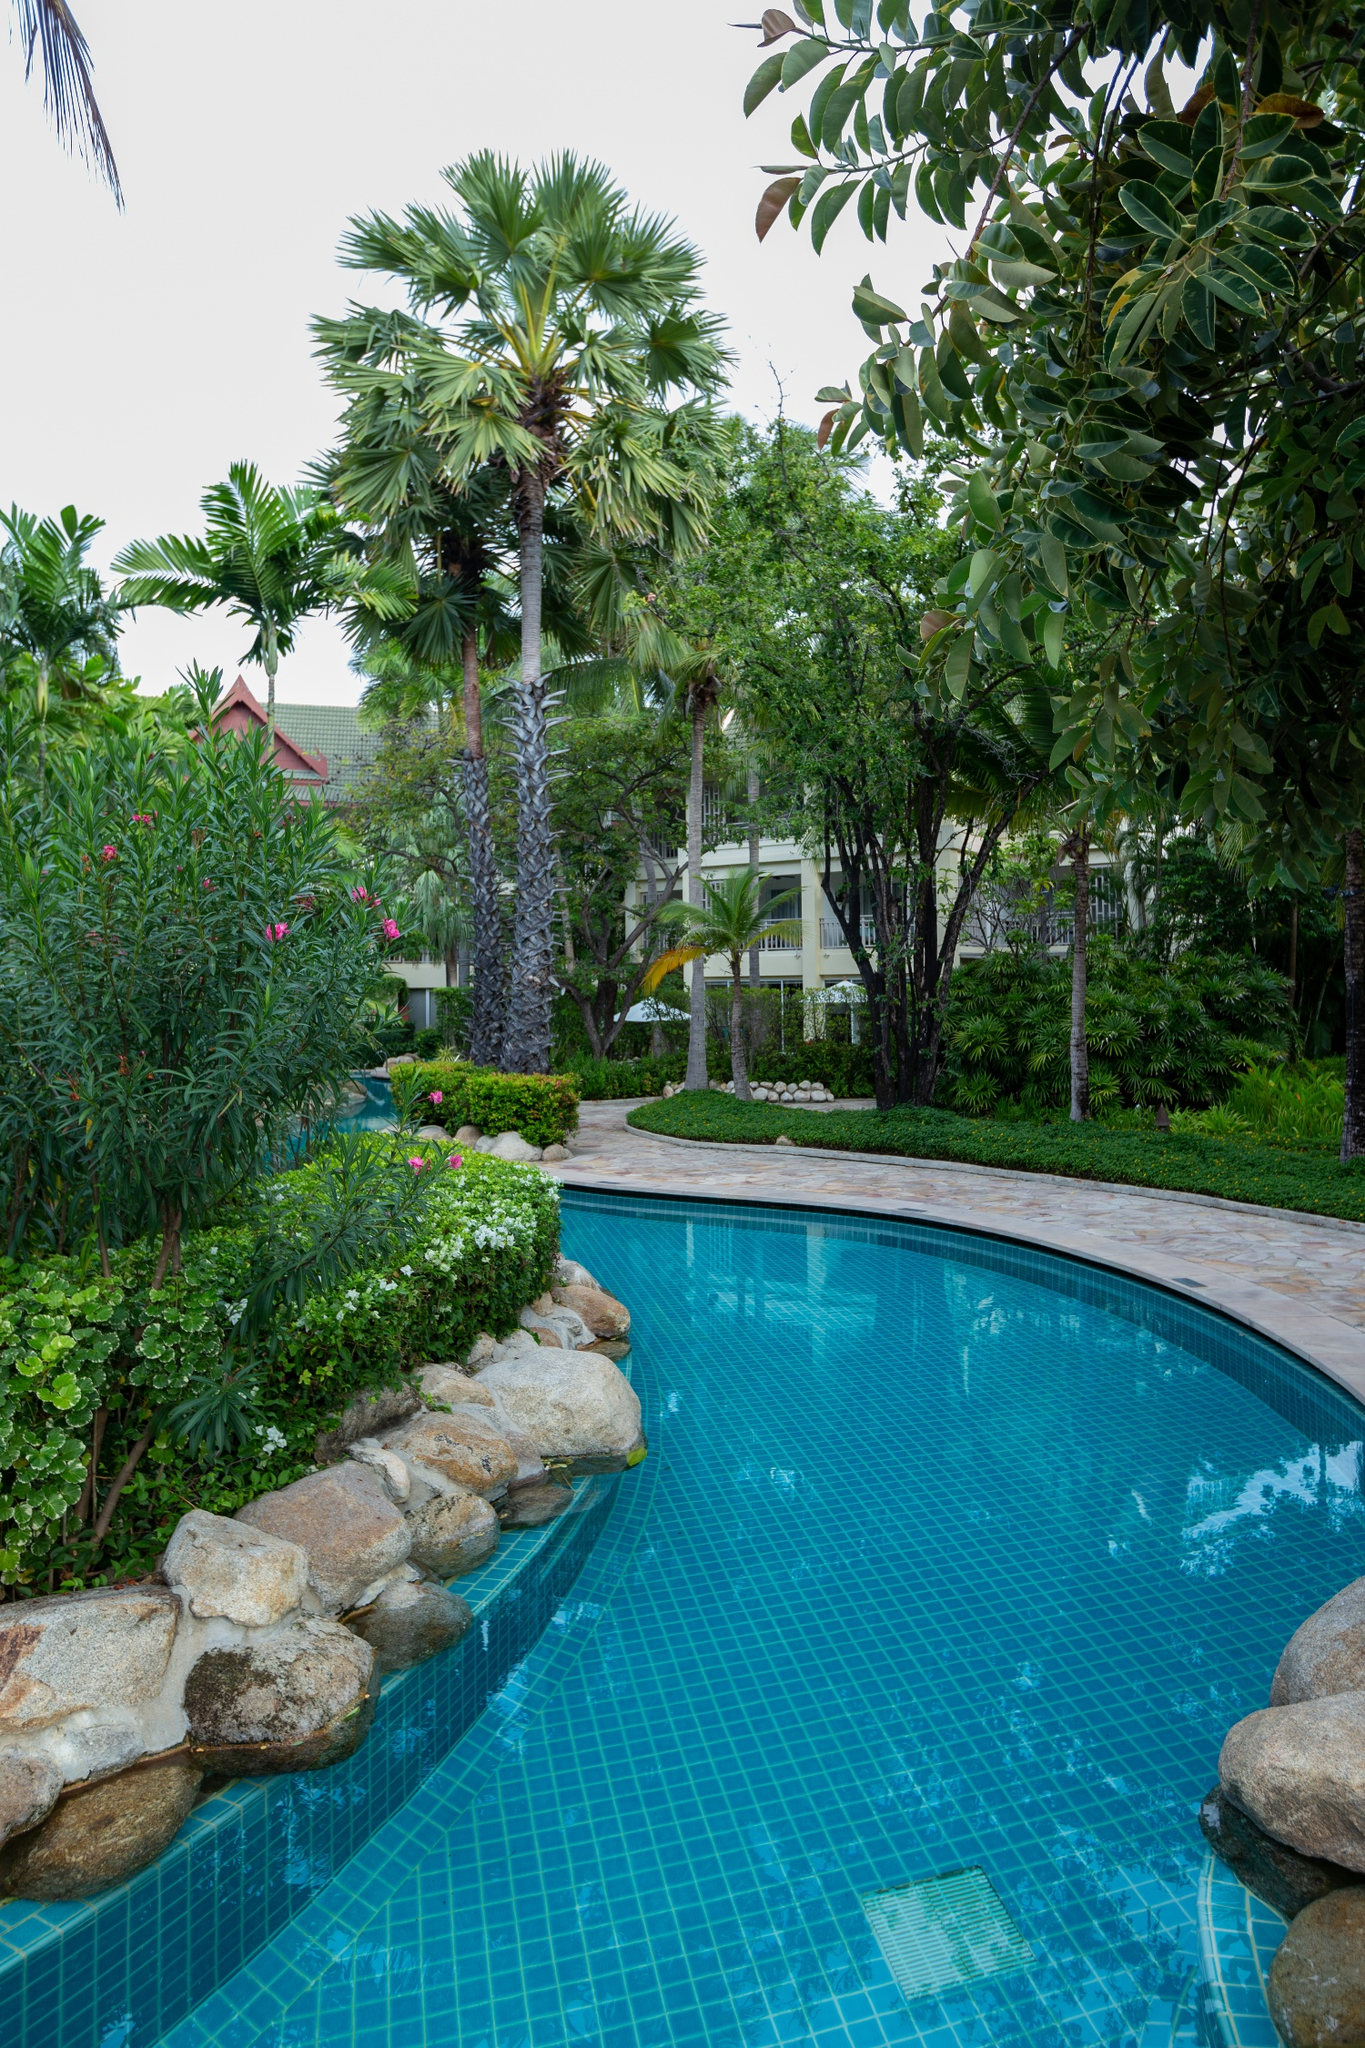This scene looks very inviting! Can you describe what types of activities guests might enjoy in this setting? Guests in this beautiful tropical resort can revel in a myriad of activities tailored for relaxation and enjoyment. Firstly, the pristine swimming pool invites guests for a leisurely swim or a playful splash under the sun. The surrounding lush garden is perfect for a peaceful stroll, where visitors can immerse themselves in the verdant greenery and vibrant blooms. The presence of palm trees suggests ample shaded areas ideal for reading a book or simply lounging. The white building in the background likely houses amenities like a spa, where guests can indulge in refreshing massages and wellness treatments, or a fine dining restaurant offering delectable local and international cuisines. This setting is ideal for sunbathing, yoga sessions amidst nature, or even a romantic evening walk as the sun sets. Overall, it’s a haven for those seeking a blissful escape from the hustle and bustle of everyday life. 